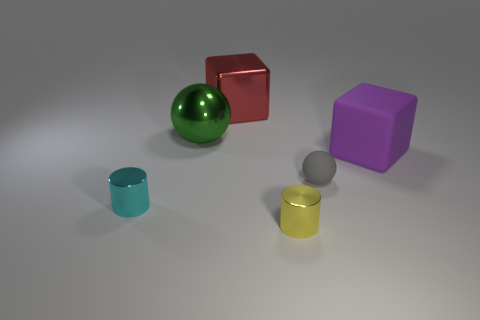Subtract all cyan cylinders. Subtract all yellow blocks. How many cylinders are left? 1 Add 4 shiny blocks. How many objects exist? 10 Add 2 yellow metal cylinders. How many yellow metal cylinders exist? 3 Subtract 0 gray cylinders. How many objects are left? 6 Subtract all tiny yellow shiny blocks. Subtract all large purple objects. How many objects are left? 5 Add 2 cyan shiny objects. How many cyan shiny objects are left? 3 